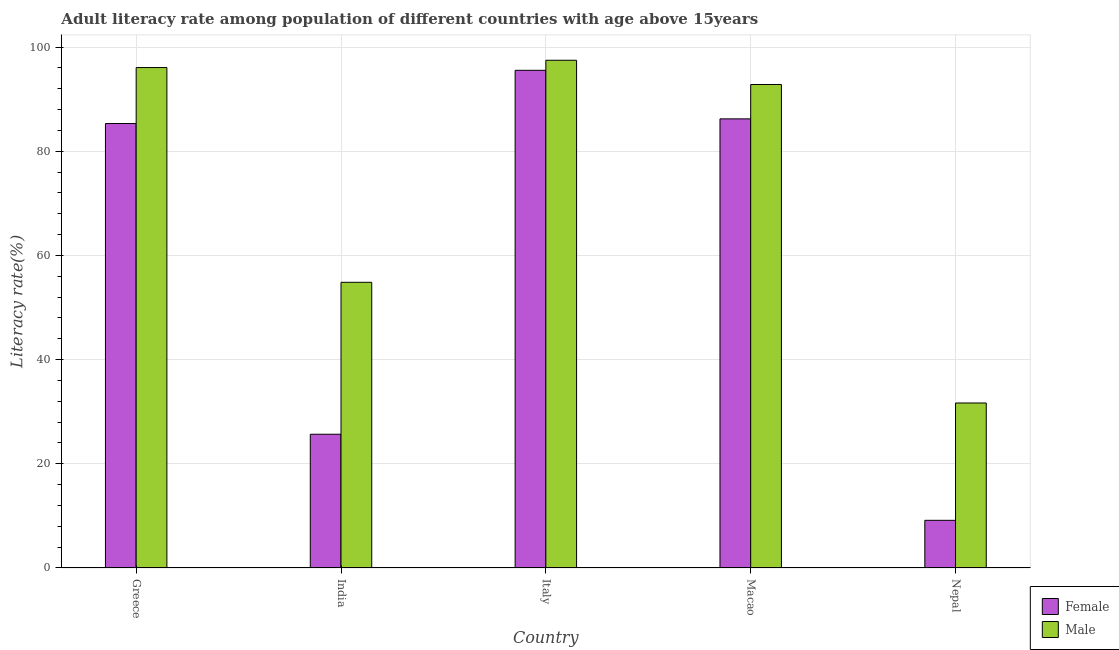Are the number of bars per tick equal to the number of legend labels?
Keep it short and to the point. Yes. Are the number of bars on each tick of the X-axis equal?
Make the answer very short. Yes. How many bars are there on the 5th tick from the left?
Your answer should be compact. 2. How many bars are there on the 5th tick from the right?
Ensure brevity in your answer.  2. What is the label of the 1st group of bars from the left?
Make the answer very short. Greece. In how many cases, is the number of bars for a given country not equal to the number of legend labels?
Provide a succinct answer. 0. What is the female adult literacy rate in Italy?
Provide a short and direct response. 95.54. Across all countries, what is the maximum female adult literacy rate?
Ensure brevity in your answer.  95.54. Across all countries, what is the minimum male adult literacy rate?
Ensure brevity in your answer.  31.67. In which country was the male adult literacy rate minimum?
Your response must be concise. Nepal. What is the total male adult literacy rate in the graph?
Provide a short and direct response. 372.85. What is the difference between the male adult literacy rate in Italy and that in Nepal?
Your answer should be compact. 65.79. What is the difference between the male adult literacy rate in Italy and the female adult literacy rate in India?
Your answer should be very brief. 71.79. What is the average male adult literacy rate per country?
Make the answer very short. 74.57. What is the difference between the male adult literacy rate and female adult literacy rate in India?
Offer a terse response. 29.16. What is the ratio of the female adult literacy rate in Greece to that in Italy?
Provide a succinct answer. 0.89. Is the male adult literacy rate in Italy less than that in Macao?
Provide a short and direct response. No. What is the difference between the highest and the second highest female adult literacy rate?
Give a very brief answer. 9.32. What is the difference between the highest and the lowest male adult literacy rate?
Make the answer very short. 65.79. Is the sum of the male adult literacy rate in India and Macao greater than the maximum female adult literacy rate across all countries?
Ensure brevity in your answer.  Yes. What does the 1st bar from the left in Greece represents?
Provide a succinct answer. Female. What does the 2nd bar from the right in India represents?
Provide a succinct answer. Female. How many bars are there?
Ensure brevity in your answer.  10. What is the difference between two consecutive major ticks on the Y-axis?
Offer a terse response. 20. Are the values on the major ticks of Y-axis written in scientific E-notation?
Your answer should be very brief. No. Does the graph contain any zero values?
Your answer should be compact. No. Where does the legend appear in the graph?
Your answer should be very brief. Bottom right. How are the legend labels stacked?
Provide a succinct answer. Vertical. What is the title of the graph?
Offer a terse response. Adult literacy rate among population of different countries with age above 15years. Does "Fraud firms" appear as one of the legend labels in the graph?
Provide a short and direct response. No. What is the label or title of the X-axis?
Offer a very short reply. Country. What is the label or title of the Y-axis?
Offer a very short reply. Literacy rate(%). What is the Literacy rate(%) of Female in Greece?
Make the answer very short. 85.32. What is the Literacy rate(%) in Male in Greece?
Your answer should be very brief. 96.06. What is the Literacy rate(%) of Female in India?
Your response must be concise. 25.68. What is the Literacy rate(%) of Male in India?
Make the answer very short. 54.84. What is the Literacy rate(%) in Female in Italy?
Make the answer very short. 95.54. What is the Literacy rate(%) in Male in Italy?
Provide a short and direct response. 97.46. What is the Literacy rate(%) in Female in Macao?
Keep it short and to the point. 86.22. What is the Literacy rate(%) of Male in Macao?
Your response must be concise. 92.81. What is the Literacy rate(%) in Female in Nepal?
Provide a short and direct response. 9.15. What is the Literacy rate(%) in Male in Nepal?
Your answer should be compact. 31.67. Across all countries, what is the maximum Literacy rate(%) of Female?
Keep it short and to the point. 95.54. Across all countries, what is the maximum Literacy rate(%) of Male?
Offer a terse response. 97.46. Across all countries, what is the minimum Literacy rate(%) in Female?
Offer a terse response. 9.15. Across all countries, what is the minimum Literacy rate(%) in Male?
Offer a very short reply. 31.67. What is the total Literacy rate(%) in Female in the graph?
Your answer should be compact. 301.9. What is the total Literacy rate(%) in Male in the graph?
Offer a very short reply. 372.85. What is the difference between the Literacy rate(%) of Female in Greece and that in India?
Offer a very short reply. 59.64. What is the difference between the Literacy rate(%) of Male in Greece and that in India?
Offer a terse response. 41.22. What is the difference between the Literacy rate(%) of Female in Greece and that in Italy?
Provide a succinct answer. -10.22. What is the difference between the Literacy rate(%) in Male in Greece and that in Italy?
Give a very brief answer. -1.4. What is the difference between the Literacy rate(%) of Female in Greece and that in Macao?
Provide a succinct answer. -0.9. What is the difference between the Literacy rate(%) of Male in Greece and that in Macao?
Provide a succinct answer. 3.25. What is the difference between the Literacy rate(%) of Female in Greece and that in Nepal?
Keep it short and to the point. 76.17. What is the difference between the Literacy rate(%) in Male in Greece and that in Nepal?
Keep it short and to the point. 64.39. What is the difference between the Literacy rate(%) of Female in India and that in Italy?
Your answer should be compact. -69.86. What is the difference between the Literacy rate(%) in Male in India and that in Italy?
Your answer should be very brief. -42.62. What is the difference between the Literacy rate(%) of Female in India and that in Macao?
Offer a very short reply. -60.54. What is the difference between the Literacy rate(%) of Male in India and that in Macao?
Keep it short and to the point. -37.97. What is the difference between the Literacy rate(%) of Female in India and that in Nepal?
Offer a terse response. 16.52. What is the difference between the Literacy rate(%) in Male in India and that in Nepal?
Your answer should be compact. 23.17. What is the difference between the Literacy rate(%) of Female in Italy and that in Macao?
Keep it short and to the point. 9.32. What is the difference between the Literacy rate(%) in Male in Italy and that in Macao?
Your response must be concise. 4.66. What is the difference between the Literacy rate(%) of Female in Italy and that in Nepal?
Keep it short and to the point. 86.38. What is the difference between the Literacy rate(%) in Male in Italy and that in Nepal?
Your answer should be compact. 65.79. What is the difference between the Literacy rate(%) of Female in Macao and that in Nepal?
Provide a succinct answer. 77.06. What is the difference between the Literacy rate(%) in Male in Macao and that in Nepal?
Ensure brevity in your answer.  61.14. What is the difference between the Literacy rate(%) in Female in Greece and the Literacy rate(%) in Male in India?
Your response must be concise. 30.48. What is the difference between the Literacy rate(%) in Female in Greece and the Literacy rate(%) in Male in Italy?
Provide a short and direct response. -12.14. What is the difference between the Literacy rate(%) of Female in Greece and the Literacy rate(%) of Male in Macao?
Offer a very short reply. -7.49. What is the difference between the Literacy rate(%) in Female in Greece and the Literacy rate(%) in Male in Nepal?
Keep it short and to the point. 53.65. What is the difference between the Literacy rate(%) of Female in India and the Literacy rate(%) of Male in Italy?
Offer a very short reply. -71.79. What is the difference between the Literacy rate(%) of Female in India and the Literacy rate(%) of Male in Macao?
Your answer should be very brief. -67.13. What is the difference between the Literacy rate(%) of Female in India and the Literacy rate(%) of Male in Nepal?
Offer a terse response. -6. What is the difference between the Literacy rate(%) of Female in Italy and the Literacy rate(%) of Male in Macao?
Keep it short and to the point. 2.73. What is the difference between the Literacy rate(%) of Female in Italy and the Literacy rate(%) of Male in Nepal?
Provide a succinct answer. 63.86. What is the difference between the Literacy rate(%) of Female in Macao and the Literacy rate(%) of Male in Nepal?
Your answer should be compact. 54.54. What is the average Literacy rate(%) of Female per country?
Provide a short and direct response. 60.38. What is the average Literacy rate(%) of Male per country?
Give a very brief answer. 74.57. What is the difference between the Literacy rate(%) of Female and Literacy rate(%) of Male in Greece?
Your response must be concise. -10.74. What is the difference between the Literacy rate(%) of Female and Literacy rate(%) of Male in India?
Keep it short and to the point. -29.16. What is the difference between the Literacy rate(%) of Female and Literacy rate(%) of Male in Italy?
Ensure brevity in your answer.  -1.93. What is the difference between the Literacy rate(%) in Female and Literacy rate(%) in Male in Macao?
Your answer should be compact. -6.59. What is the difference between the Literacy rate(%) of Female and Literacy rate(%) of Male in Nepal?
Give a very brief answer. -22.52. What is the ratio of the Literacy rate(%) of Female in Greece to that in India?
Offer a very short reply. 3.32. What is the ratio of the Literacy rate(%) of Male in Greece to that in India?
Keep it short and to the point. 1.75. What is the ratio of the Literacy rate(%) of Female in Greece to that in Italy?
Your response must be concise. 0.89. What is the ratio of the Literacy rate(%) in Male in Greece to that in Italy?
Keep it short and to the point. 0.99. What is the ratio of the Literacy rate(%) in Male in Greece to that in Macao?
Offer a very short reply. 1.04. What is the ratio of the Literacy rate(%) of Female in Greece to that in Nepal?
Provide a succinct answer. 9.32. What is the ratio of the Literacy rate(%) of Male in Greece to that in Nepal?
Ensure brevity in your answer.  3.03. What is the ratio of the Literacy rate(%) in Female in India to that in Italy?
Provide a short and direct response. 0.27. What is the ratio of the Literacy rate(%) of Male in India to that in Italy?
Give a very brief answer. 0.56. What is the ratio of the Literacy rate(%) in Female in India to that in Macao?
Provide a succinct answer. 0.3. What is the ratio of the Literacy rate(%) of Male in India to that in Macao?
Provide a short and direct response. 0.59. What is the ratio of the Literacy rate(%) of Female in India to that in Nepal?
Offer a very short reply. 2.81. What is the ratio of the Literacy rate(%) in Male in India to that in Nepal?
Make the answer very short. 1.73. What is the ratio of the Literacy rate(%) in Female in Italy to that in Macao?
Your response must be concise. 1.11. What is the ratio of the Literacy rate(%) in Male in Italy to that in Macao?
Provide a short and direct response. 1.05. What is the ratio of the Literacy rate(%) of Female in Italy to that in Nepal?
Your response must be concise. 10.44. What is the ratio of the Literacy rate(%) in Male in Italy to that in Nepal?
Your answer should be compact. 3.08. What is the ratio of the Literacy rate(%) in Female in Macao to that in Nepal?
Your response must be concise. 9.42. What is the ratio of the Literacy rate(%) in Male in Macao to that in Nepal?
Provide a succinct answer. 2.93. What is the difference between the highest and the second highest Literacy rate(%) in Female?
Your response must be concise. 9.32. What is the difference between the highest and the second highest Literacy rate(%) of Male?
Your response must be concise. 1.4. What is the difference between the highest and the lowest Literacy rate(%) of Female?
Make the answer very short. 86.38. What is the difference between the highest and the lowest Literacy rate(%) in Male?
Provide a succinct answer. 65.79. 